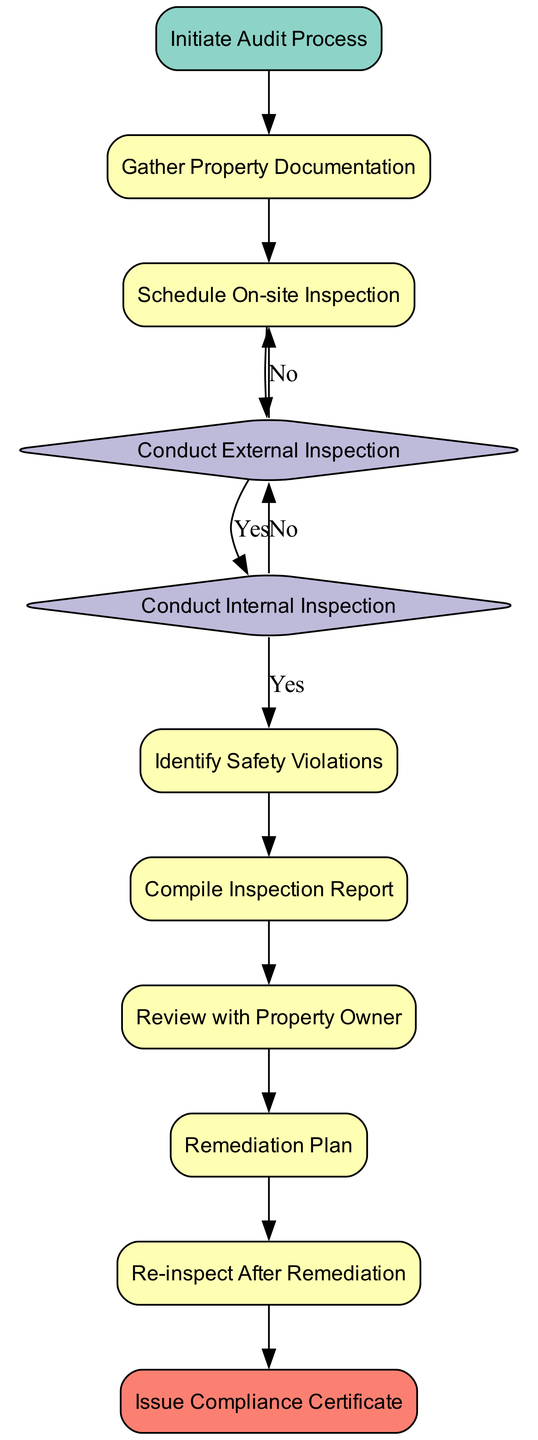What is the first step in the audit process? The first step in the flowchart is "Initiate Audit Process", which marks the beginning of the entire audit for the residential property.
Answer: Initiate Audit Process How many main processes are there in the flowchart? Counting the nodes that are categorized as 'process', we identify several processes: "Gather Property Documentation", "Schedule On-site Inspection", "Identify Safety Violations", "Compile Inspection Report", "Review with Property Owner", "Remediation Plan", and "Re-inspect After Remediation". There are a total of six main processes.
Answer: Six What happens after conducting the external inspection if safety standards are not met? After the "Conduct External Inspection", if the inspection reveals that safety standards are not met, the flowchart indicates going back to the process to identify safety violations, which means that the identified issues must be documented before continuing further.
Answer: Identify Safety Violations What is the final step of the audit process? The final step in the flowchart is "Issue Compliance Certificate", which signifies the end of the process where a certification is given that the property meets all safety and compliance standards.
Answer: Issue Compliance Certificate How many decision points are there in the flowchart? The flowchart has two decision points; one after "Conduct External Inspection" and another after "Conduct Internal Inspection." Each decision represents a need to evaluate whether the property meets safety standards or compliance.
Answer: Two What must happen before a compliance certificate can be issued? Before a compliance certificate can be issued, the property must be re-inspected after remediation to ensure that all identified issues have been correctly addressed and resolved.
Answer: Re-inspect After Remediation What is discussed with the property owner during the audit process? During the "Review with Property Owner" step, the inspection results are discussed, specifically highlighting areas of concern and recommended actions that need to be taken regarding the safety violations found during the inspection.
Answer: Inspection results What document is prepared after identifying safety violations? After identifying safety violations, the next step in the flowchart is to "Compile Inspection Report", which is a detailed report summarizing all findings from both the external and internal inspections related to safety and compliance.
Answer: Compile Inspection Report 